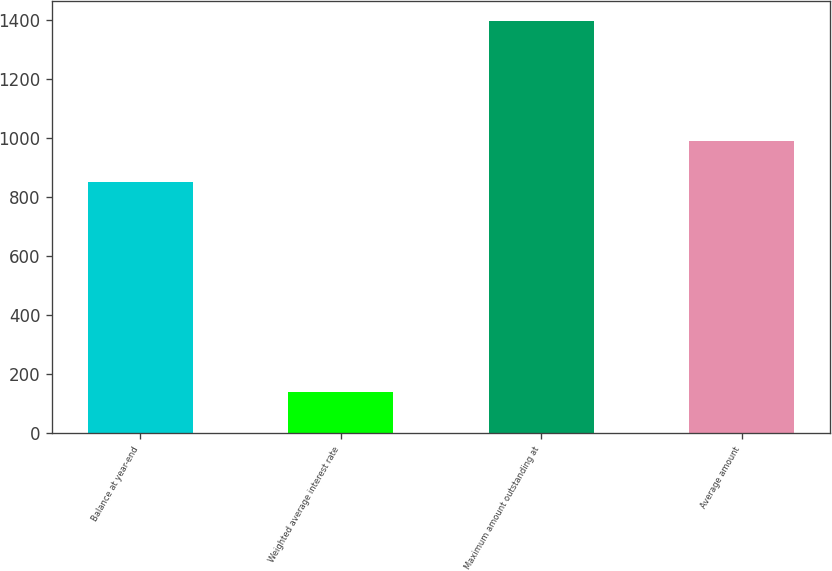Convert chart to OTSL. <chart><loc_0><loc_0><loc_500><loc_500><bar_chart><fcel>Balance at year-end<fcel>Weighted average interest rate<fcel>Maximum amount outstanding at<fcel>Average amount<nl><fcel>851<fcel>139.68<fcel>1395<fcel>990.48<nl></chart> 